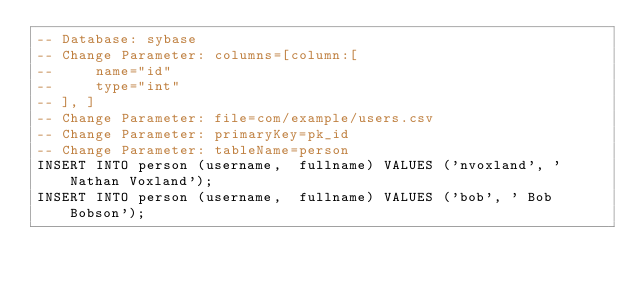<code> <loc_0><loc_0><loc_500><loc_500><_SQL_>-- Database: sybase
-- Change Parameter: columns=[column:[
--     name="id"
--     type="int"
-- ], ]
-- Change Parameter: file=com/example/users.csv
-- Change Parameter: primaryKey=pk_id
-- Change Parameter: tableName=person
INSERT INTO person (username,  fullname) VALUES ('nvoxland', ' Nathan Voxland');
INSERT INTO person (username,  fullname) VALUES ('bob', ' Bob Bobson');
</code> 